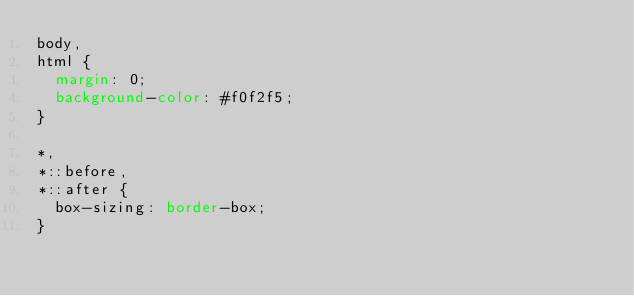Convert code to text. <code><loc_0><loc_0><loc_500><loc_500><_CSS_>body,
html {
  margin: 0;
  background-color: #f0f2f5;
}

*,
*::before,
*::after {
  box-sizing: border-box;
}
</code> 